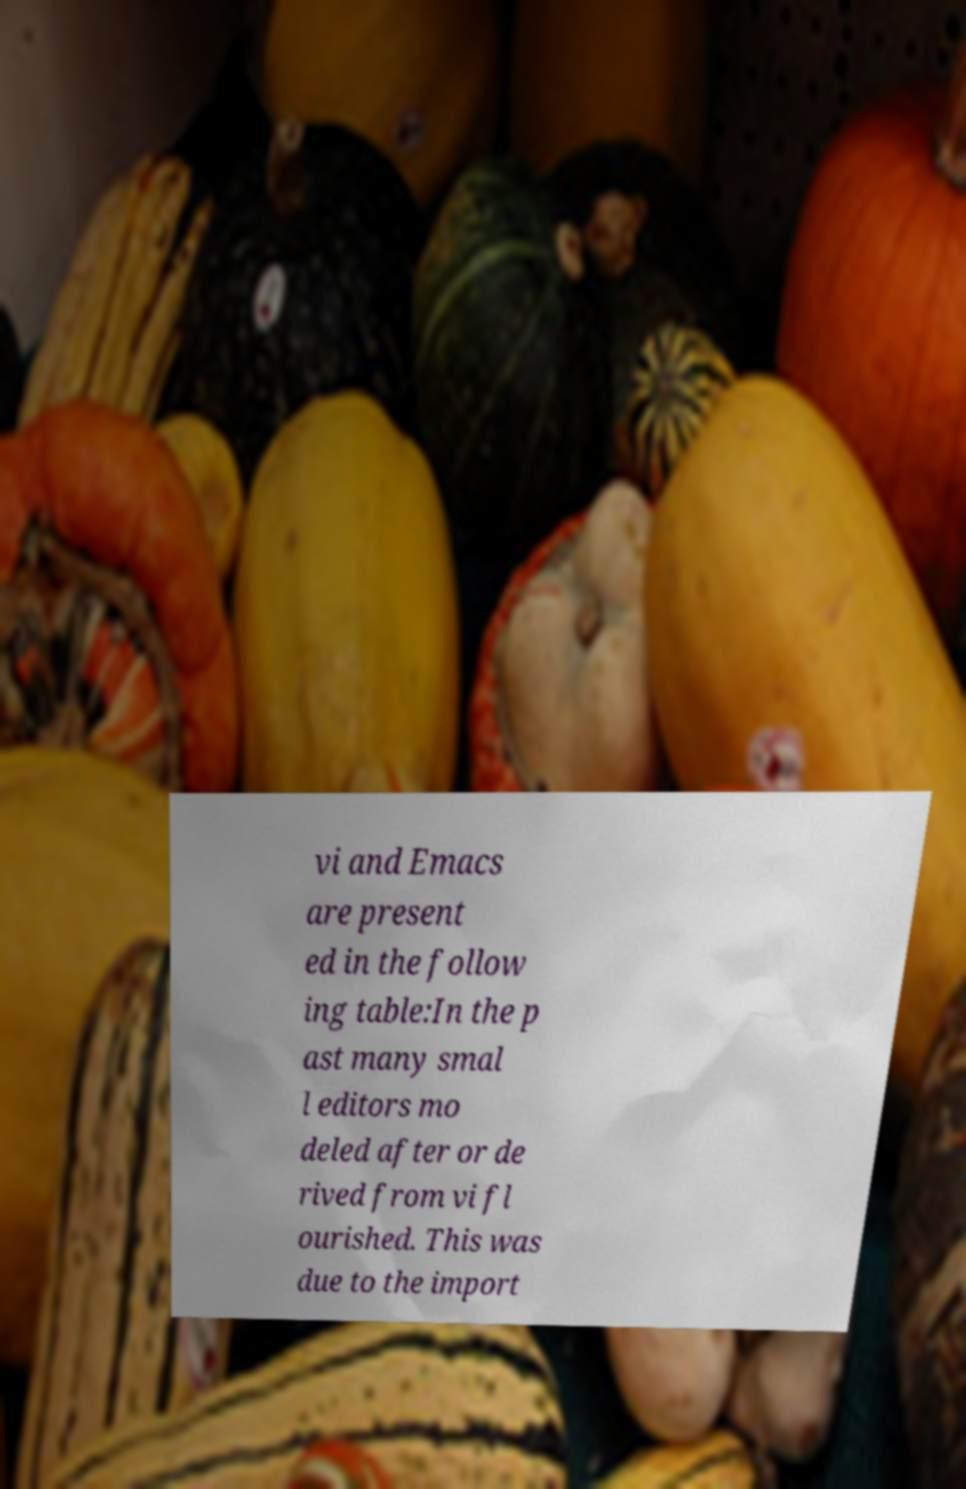Could you extract and type out the text from this image? vi and Emacs are present ed in the follow ing table:In the p ast many smal l editors mo deled after or de rived from vi fl ourished. This was due to the import 